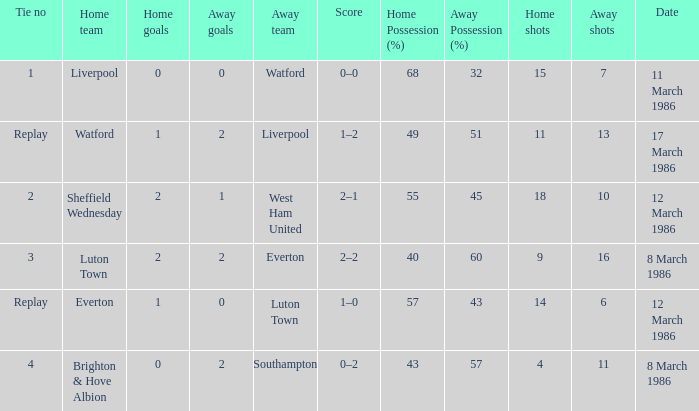Who was the home team in the match against Luton Town? Everton. Could you parse the entire table as a dict? {'header': ['Tie no', 'Home team', 'Home goals', 'Away goals', 'Away team', 'Score', 'Home Possession (%)', 'Away Possession (%)', 'Home shots', 'Away shots', 'Date'], 'rows': [['1', 'Liverpool', '0', '0', 'Watford', '0–0', '68', '32', '15', '7', '11 March 1986'], ['Replay', 'Watford', '1', '2', 'Liverpool', '1–2', '49', '51', '11', '13', '17 March 1986'], ['2', 'Sheffield Wednesday', '2', '1', 'West Ham United', '2–1', '55', '45', '18', '10', '12 March 1986'], ['3', 'Luton Town', '2', '2', 'Everton', '2–2', '40', '60', '9', '16', '8 March 1986'], ['Replay', 'Everton', '1', '0', 'Luton Town', '1–0', '57', '43', '14', '6', '12 March 1986'], ['4', 'Brighton & Hove Albion', '0', '2', 'Southampton', '0–2', '43', '57', '4', '11', '8 March 1986']]} 